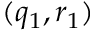<formula> <loc_0><loc_0><loc_500><loc_500>( q _ { 1 } , r _ { 1 } )</formula> 